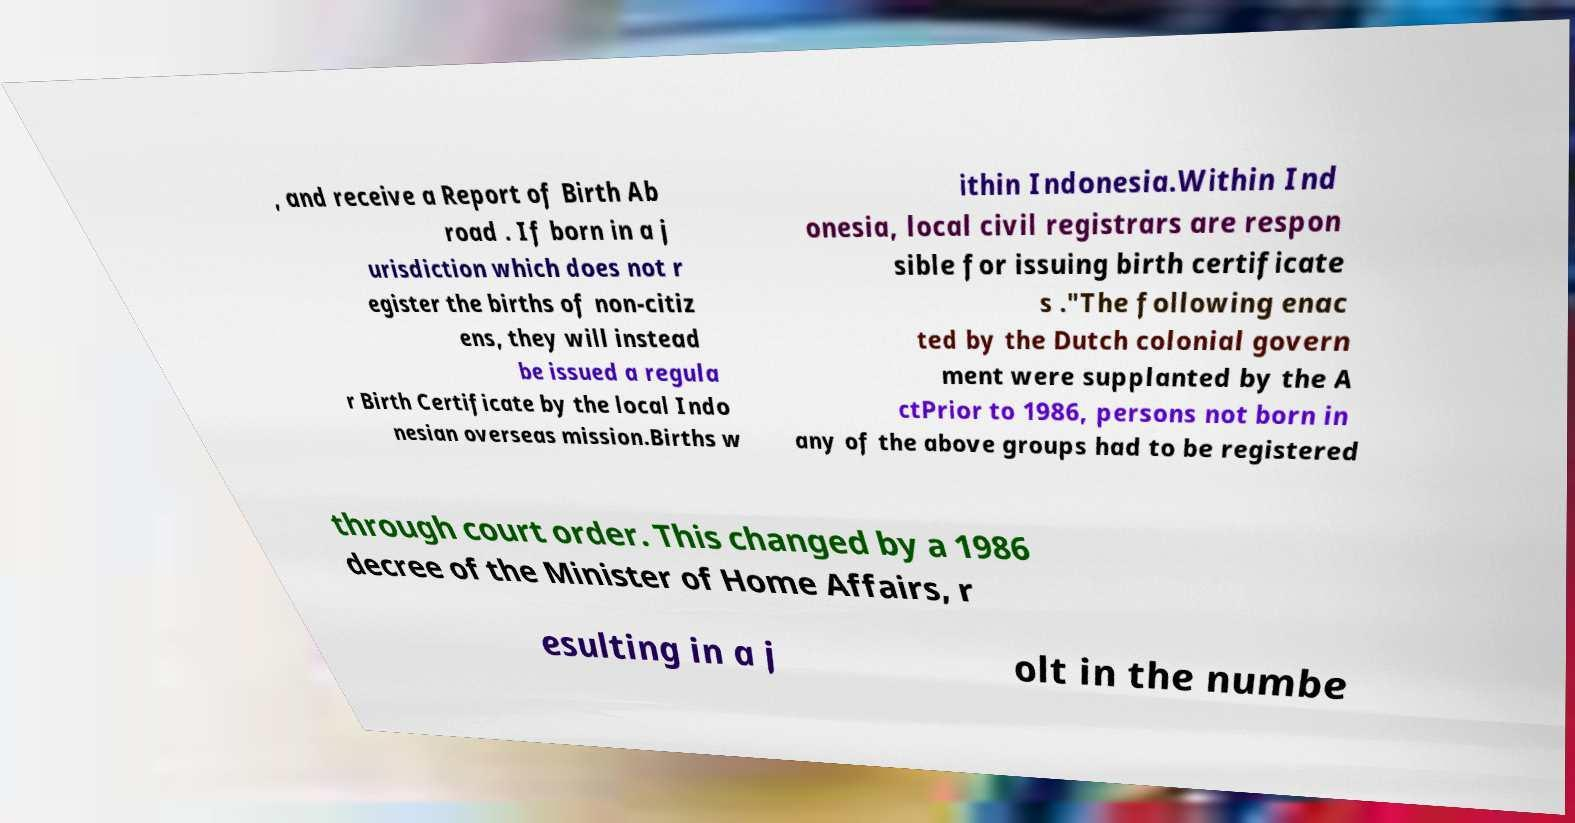Please read and relay the text visible in this image. What does it say? , and receive a Report of Birth Ab road . If born in a j urisdiction which does not r egister the births of non-citiz ens, they will instead be issued a regula r Birth Certificate by the local Indo nesian overseas mission.Births w ithin Indonesia.Within Ind onesia, local civil registrars are respon sible for issuing birth certificate s ."The following enac ted by the Dutch colonial govern ment were supplanted by the A ctPrior to 1986, persons not born in any of the above groups had to be registered through court order. This changed by a 1986 decree of the Minister of Home Affairs, r esulting in a j olt in the numbe 